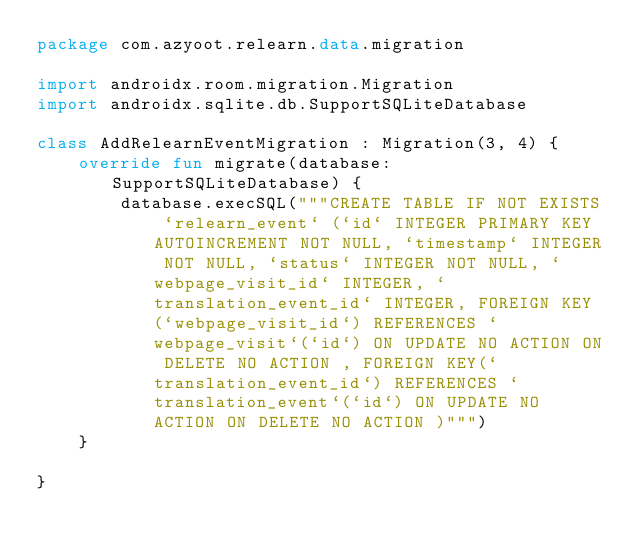Convert code to text. <code><loc_0><loc_0><loc_500><loc_500><_Kotlin_>package com.azyoot.relearn.data.migration

import androidx.room.migration.Migration
import androidx.sqlite.db.SupportSQLiteDatabase

class AddRelearnEventMigration : Migration(3, 4) {
    override fun migrate(database: SupportSQLiteDatabase) {
        database.execSQL("""CREATE TABLE IF NOT EXISTS `relearn_event` (`id` INTEGER PRIMARY KEY AUTOINCREMENT NOT NULL, `timestamp` INTEGER NOT NULL, `status` INTEGER NOT NULL, `webpage_visit_id` INTEGER, `translation_event_id` INTEGER, FOREIGN KEY(`webpage_visit_id`) REFERENCES `webpage_visit`(`id`) ON UPDATE NO ACTION ON DELETE NO ACTION , FOREIGN KEY(`translation_event_id`) REFERENCES `translation_event`(`id`) ON UPDATE NO ACTION ON DELETE NO ACTION )""")
    }

}</code> 